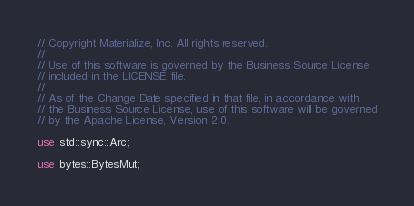Convert code to text. <code><loc_0><loc_0><loc_500><loc_500><_Rust_>// Copyright Materialize, Inc. All rights reserved.
//
// Use of this software is governed by the Business Source License
// included in the LICENSE file.
//
// As of the Change Date specified in that file, in accordance with
// the Business Source License, use of this software will be governed
// by the Apache License, Version 2.0.

use std::sync::Arc;

use bytes::BytesMut;
</code> 